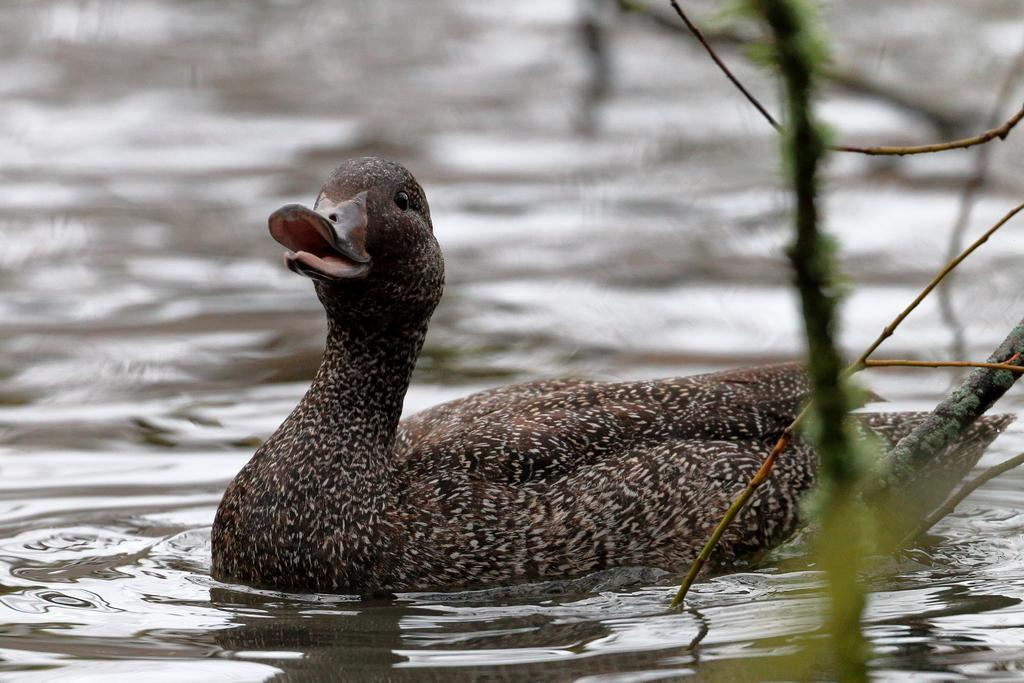What animal is present in the image? There is a duck in the image. What is the duck doing in the image? The duck is swimming on the water. What can be seen on the right side of the image? There is a plant on the right side of the image. What type of oven is visible in the image? There is no oven present in the image. Who is the creator of the duck in the image? The image is a photograph or illustration, not a creation by a specific individual. 